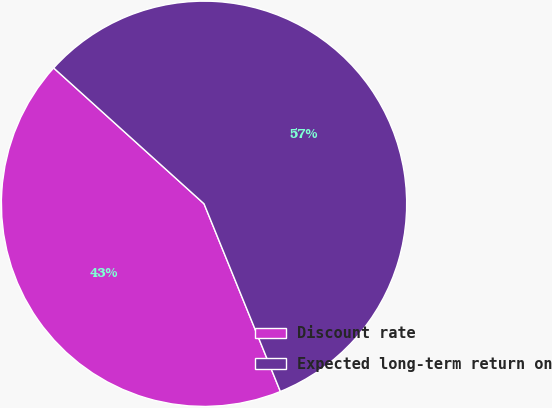Convert chart to OTSL. <chart><loc_0><loc_0><loc_500><loc_500><pie_chart><fcel>Discount rate<fcel>Expected long-term return on<nl><fcel>42.84%<fcel>57.16%<nl></chart> 